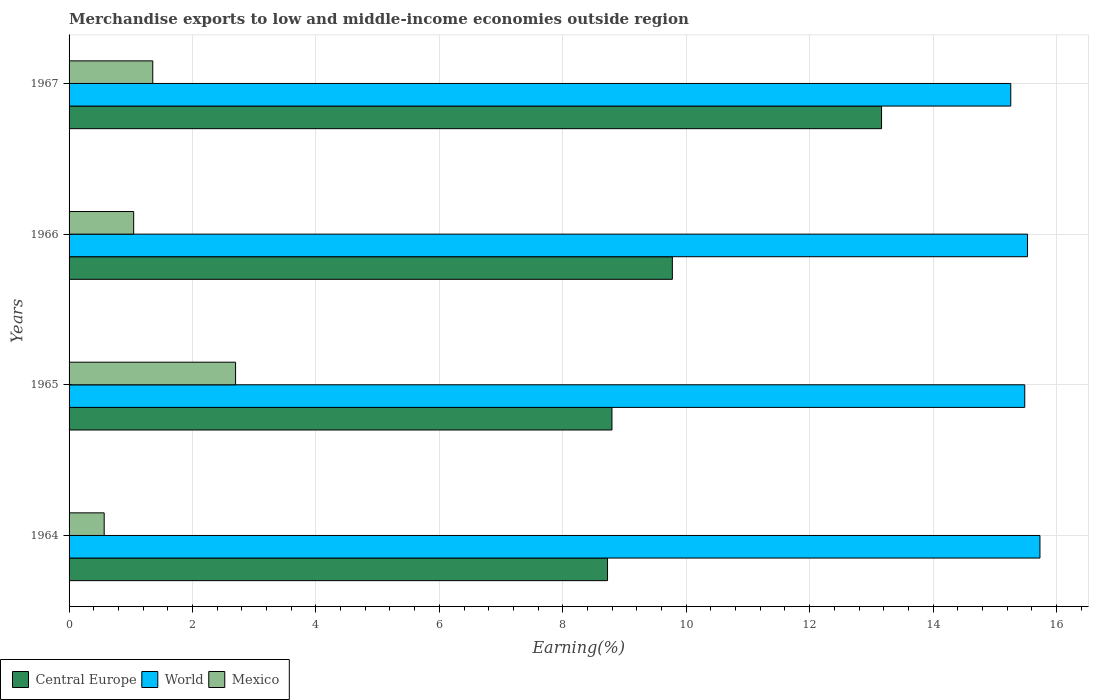How many different coloured bars are there?
Make the answer very short. 3. Are the number of bars per tick equal to the number of legend labels?
Ensure brevity in your answer.  Yes. Are the number of bars on each tick of the Y-axis equal?
Keep it short and to the point. Yes. How many bars are there on the 1st tick from the top?
Your answer should be compact. 3. How many bars are there on the 1st tick from the bottom?
Provide a succinct answer. 3. What is the label of the 1st group of bars from the top?
Offer a very short reply. 1967. In how many cases, is the number of bars for a given year not equal to the number of legend labels?
Your answer should be very brief. 0. What is the percentage of amount earned from merchandise exports in Mexico in 1965?
Offer a terse response. 2.7. Across all years, what is the maximum percentage of amount earned from merchandise exports in Mexico?
Give a very brief answer. 2.7. Across all years, what is the minimum percentage of amount earned from merchandise exports in World?
Ensure brevity in your answer.  15.26. In which year was the percentage of amount earned from merchandise exports in World maximum?
Your response must be concise. 1964. In which year was the percentage of amount earned from merchandise exports in World minimum?
Provide a succinct answer. 1967. What is the total percentage of amount earned from merchandise exports in World in the graph?
Give a very brief answer. 62.01. What is the difference between the percentage of amount earned from merchandise exports in Mexico in 1965 and that in 1967?
Your answer should be compact. 1.34. What is the difference between the percentage of amount earned from merchandise exports in Mexico in 1966 and the percentage of amount earned from merchandise exports in Central Europe in 1967?
Ensure brevity in your answer.  -12.12. What is the average percentage of amount earned from merchandise exports in Mexico per year?
Keep it short and to the point. 1.42. In the year 1964, what is the difference between the percentage of amount earned from merchandise exports in World and percentage of amount earned from merchandise exports in Mexico?
Offer a very short reply. 15.16. What is the ratio of the percentage of amount earned from merchandise exports in Central Europe in 1964 to that in 1966?
Ensure brevity in your answer.  0.89. Is the percentage of amount earned from merchandise exports in Central Europe in 1964 less than that in 1966?
Make the answer very short. Yes. Is the difference between the percentage of amount earned from merchandise exports in World in 1965 and 1967 greater than the difference between the percentage of amount earned from merchandise exports in Mexico in 1965 and 1967?
Make the answer very short. No. What is the difference between the highest and the second highest percentage of amount earned from merchandise exports in World?
Ensure brevity in your answer.  0.2. What is the difference between the highest and the lowest percentage of amount earned from merchandise exports in World?
Give a very brief answer. 0.47. What does the 1st bar from the bottom in 1966 represents?
Provide a succinct answer. Central Europe. Is it the case that in every year, the sum of the percentage of amount earned from merchandise exports in World and percentage of amount earned from merchandise exports in Central Europe is greater than the percentage of amount earned from merchandise exports in Mexico?
Offer a terse response. Yes. Are all the bars in the graph horizontal?
Provide a succinct answer. Yes. What is the difference between two consecutive major ticks on the X-axis?
Your answer should be very brief. 2. Are the values on the major ticks of X-axis written in scientific E-notation?
Your response must be concise. No. Does the graph contain grids?
Your response must be concise. Yes. Where does the legend appear in the graph?
Your response must be concise. Bottom left. How many legend labels are there?
Your answer should be very brief. 3. How are the legend labels stacked?
Provide a short and direct response. Horizontal. What is the title of the graph?
Make the answer very short. Merchandise exports to low and middle-income economies outside region. Does "India" appear as one of the legend labels in the graph?
Keep it short and to the point. No. What is the label or title of the X-axis?
Your answer should be compact. Earning(%). What is the label or title of the Y-axis?
Offer a very short reply. Years. What is the Earning(%) of Central Europe in 1964?
Your answer should be very brief. 8.73. What is the Earning(%) in World in 1964?
Provide a short and direct response. 15.73. What is the Earning(%) of Mexico in 1964?
Provide a succinct answer. 0.57. What is the Earning(%) in Central Europe in 1965?
Ensure brevity in your answer.  8.8. What is the Earning(%) in World in 1965?
Your answer should be compact. 15.49. What is the Earning(%) in Mexico in 1965?
Provide a short and direct response. 2.7. What is the Earning(%) of Central Europe in 1966?
Provide a short and direct response. 9.78. What is the Earning(%) in World in 1966?
Ensure brevity in your answer.  15.53. What is the Earning(%) of Mexico in 1966?
Provide a short and direct response. 1.05. What is the Earning(%) in Central Europe in 1967?
Offer a terse response. 13.17. What is the Earning(%) in World in 1967?
Provide a short and direct response. 15.26. What is the Earning(%) in Mexico in 1967?
Give a very brief answer. 1.36. Across all years, what is the maximum Earning(%) in Central Europe?
Your answer should be very brief. 13.17. Across all years, what is the maximum Earning(%) in World?
Provide a short and direct response. 15.73. Across all years, what is the maximum Earning(%) in Mexico?
Provide a succinct answer. 2.7. Across all years, what is the minimum Earning(%) of Central Europe?
Offer a terse response. 8.73. Across all years, what is the minimum Earning(%) in World?
Your answer should be very brief. 15.26. Across all years, what is the minimum Earning(%) of Mexico?
Keep it short and to the point. 0.57. What is the total Earning(%) of Central Europe in the graph?
Offer a very short reply. 40.46. What is the total Earning(%) of World in the graph?
Provide a short and direct response. 62.01. What is the total Earning(%) of Mexico in the graph?
Offer a very short reply. 5.67. What is the difference between the Earning(%) in Central Europe in 1964 and that in 1965?
Provide a short and direct response. -0.07. What is the difference between the Earning(%) in World in 1964 and that in 1965?
Keep it short and to the point. 0.25. What is the difference between the Earning(%) in Mexico in 1964 and that in 1965?
Provide a short and direct response. -2.13. What is the difference between the Earning(%) of Central Europe in 1964 and that in 1966?
Offer a terse response. -1.05. What is the difference between the Earning(%) of World in 1964 and that in 1966?
Provide a short and direct response. 0.2. What is the difference between the Earning(%) of Mexico in 1964 and that in 1966?
Give a very brief answer. -0.48. What is the difference between the Earning(%) in Central Europe in 1964 and that in 1967?
Give a very brief answer. -4.44. What is the difference between the Earning(%) in World in 1964 and that in 1967?
Your response must be concise. 0.47. What is the difference between the Earning(%) of Mexico in 1964 and that in 1967?
Make the answer very short. -0.79. What is the difference between the Earning(%) of Central Europe in 1965 and that in 1966?
Your answer should be compact. -0.98. What is the difference between the Earning(%) in World in 1965 and that in 1966?
Offer a very short reply. -0.04. What is the difference between the Earning(%) of Mexico in 1965 and that in 1966?
Keep it short and to the point. 1.65. What is the difference between the Earning(%) of Central Europe in 1965 and that in 1967?
Keep it short and to the point. -4.37. What is the difference between the Earning(%) in World in 1965 and that in 1967?
Your answer should be compact. 0.23. What is the difference between the Earning(%) in Mexico in 1965 and that in 1967?
Give a very brief answer. 1.34. What is the difference between the Earning(%) in Central Europe in 1966 and that in 1967?
Offer a terse response. -3.39. What is the difference between the Earning(%) in World in 1966 and that in 1967?
Make the answer very short. 0.27. What is the difference between the Earning(%) of Mexico in 1966 and that in 1967?
Provide a short and direct response. -0.31. What is the difference between the Earning(%) of Central Europe in 1964 and the Earning(%) of World in 1965?
Keep it short and to the point. -6.76. What is the difference between the Earning(%) of Central Europe in 1964 and the Earning(%) of Mexico in 1965?
Offer a terse response. 6.03. What is the difference between the Earning(%) in World in 1964 and the Earning(%) in Mexico in 1965?
Provide a succinct answer. 13.03. What is the difference between the Earning(%) of Central Europe in 1964 and the Earning(%) of World in 1966?
Make the answer very short. -6.81. What is the difference between the Earning(%) in Central Europe in 1964 and the Earning(%) in Mexico in 1966?
Make the answer very short. 7.68. What is the difference between the Earning(%) in World in 1964 and the Earning(%) in Mexico in 1966?
Make the answer very short. 14.69. What is the difference between the Earning(%) of Central Europe in 1964 and the Earning(%) of World in 1967?
Keep it short and to the point. -6.53. What is the difference between the Earning(%) in Central Europe in 1964 and the Earning(%) in Mexico in 1967?
Ensure brevity in your answer.  7.37. What is the difference between the Earning(%) of World in 1964 and the Earning(%) of Mexico in 1967?
Ensure brevity in your answer.  14.38. What is the difference between the Earning(%) of Central Europe in 1965 and the Earning(%) of World in 1966?
Make the answer very short. -6.73. What is the difference between the Earning(%) of Central Europe in 1965 and the Earning(%) of Mexico in 1966?
Provide a short and direct response. 7.75. What is the difference between the Earning(%) of World in 1965 and the Earning(%) of Mexico in 1966?
Keep it short and to the point. 14.44. What is the difference between the Earning(%) in Central Europe in 1965 and the Earning(%) in World in 1967?
Give a very brief answer. -6.46. What is the difference between the Earning(%) in Central Europe in 1965 and the Earning(%) in Mexico in 1967?
Provide a succinct answer. 7.44. What is the difference between the Earning(%) of World in 1965 and the Earning(%) of Mexico in 1967?
Your answer should be very brief. 14.13. What is the difference between the Earning(%) of Central Europe in 1966 and the Earning(%) of World in 1967?
Your response must be concise. -5.48. What is the difference between the Earning(%) of Central Europe in 1966 and the Earning(%) of Mexico in 1967?
Make the answer very short. 8.42. What is the difference between the Earning(%) in World in 1966 and the Earning(%) in Mexico in 1967?
Offer a terse response. 14.17. What is the average Earning(%) of Central Europe per year?
Your response must be concise. 10.12. What is the average Earning(%) in World per year?
Provide a succinct answer. 15.5. What is the average Earning(%) of Mexico per year?
Give a very brief answer. 1.42. In the year 1964, what is the difference between the Earning(%) in Central Europe and Earning(%) in World?
Keep it short and to the point. -7.01. In the year 1964, what is the difference between the Earning(%) in Central Europe and Earning(%) in Mexico?
Provide a short and direct response. 8.16. In the year 1964, what is the difference between the Earning(%) of World and Earning(%) of Mexico?
Your answer should be very brief. 15.16. In the year 1965, what is the difference between the Earning(%) in Central Europe and Earning(%) in World?
Ensure brevity in your answer.  -6.69. In the year 1965, what is the difference between the Earning(%) in Central Europe and Earning(%) in Mexico?
Your response must be concise. 6.1. In the year 1965, what is the difference between the Earning(%) of World and Earning(%) of Mexico?
Provide a short and direct response. 12.79. In the year 1966, what is the difference between the Earning(%) of Central Europe and Earning(%) of World?
Ensure brevity in your answer.  -5.76. In the year 1966, what is the difference between the Earning(%) of Central Europe and Earning(%) of Mexico?
Give a very brief answer. 8.73. In the year 1966, what is the difference between the Earning(%) in World and Earning(%) in Mexico?
Ensure brevity in your answer.  14.48. In the year 1967, what is the difference between the Earning(%) in Central Europe and Earning(%) in World?
Offer a terse response. -2.09. In the year 1967, what is the difference between the Earning(%) of Central Europe and Earning(%) of Mexico?
Provide a succinct answer. 11.81. In the year 1967, what is the difference between the Earning(%) of World and Earning(%) of Mexico?
Your answer should be very brief. 13.9. What is the ratio of the Earning(%) in Central Europe in 1964 to that in 1965?
Give a very brief answer. 0.99. What is the ratio of the Earning(%) of World in 1964 to that in 1965?
Provide a succinct answer. 1.02. What is the ratio of the Earning(%) of Mexico in 1964 to that in 1965?
Make the answer very short. 0.21. What is the ratio of the Earning(%) of Central Europe in 1964 to that in 1966?
Offer a terse response. 0.89. What is the ratio of the Earning(%) of World in 1964 to that in 1966?
Offer a terse response. 1.01. What is the ratio of the Earning(%) in Mexico in 1964 to that in 1966?
Provide a succinct answer. 0.54. What is the ratio of the Earning(%) of Central Europe in 1964 to that in 1967?
Make the answer very short. 0.66. What is the ratio of the Earning(%) in World in 1964 to that in 1967?
Make the answer very short. 1.03. What is the ratio of the Earning(%) in Mexico in 1964 to that in 1967?
Keep it short and to the point. 0.42. What is the ratio of the Earning(%) in Central Europe in 1965 to that in 1966?
Give a very brief answer. 0.9. What is the ratio of the Earning(%) of Mexico in 1965 to that in 1966?
Provide a short and direct response. 2.58. What is the ratio of the Earning(%) in Central Europe in 1965 to that in 1967?
Ensure brevity in your answer.  0.67. What is the ratio of the Earning(%) in World in 1965 to that in 1967?
Your response must be concise. 1.01. What is the ratio of the Earning(%) of Mexico in 1965 to that in 1967?
Provide a short and direct response. 1.99. What is the ratio of the Earning(%) in Central Europe in 1966 to that in 1967?
Give a very brief answer. 0.74. What is the ratio of the Earning(%) of World in 1966 to that in 1967?
Your answer should be compact. 1.02. What is the ratio of the Earning(%) in Mexico in 1966 to that in 1967?
Your answer should be very brief. 0.77. What is the difference between the highest and the second highest Earning(%) of Central Europe?
Your answer should be compact. 3.39. What is the difference between the highest and the second highest Earning(%) in World?
Your answer should be compact. 0.2. What is the difference between the highest and the second highest Earning(%) of Mexico?
Your answer should be compact. 1.34. What is the difference between the highest and the lowest Earning(%) of Central Europe?
Ensure brevity in your answer.  4.44. What is the difference between the highest and the lowest Earning(%) of World?
Your answer should be very brief. 0.47. What is the difference between the highest and the lowest Earning(%) in Mexico?
Give a very brief answer. 2.13. 